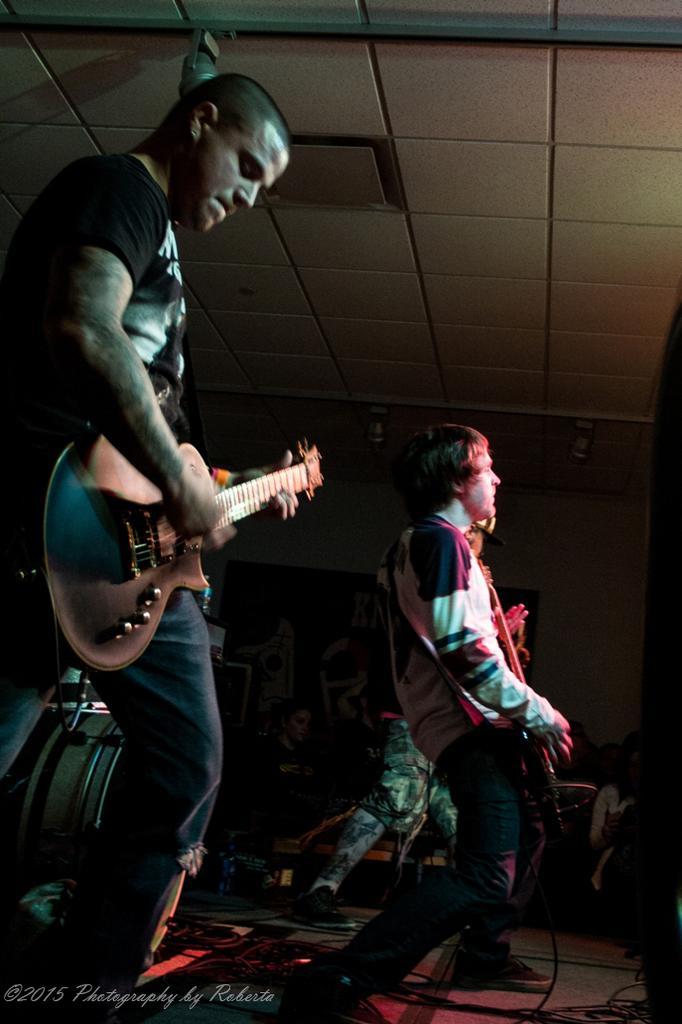Please provide a concise description of this image. This picture is of inside. On the right there is a man seems to be playing guitar and standing. On the left there is a man wearing black color t-shirt, playing guitar and standing. In the background there is a wall and some persons. 